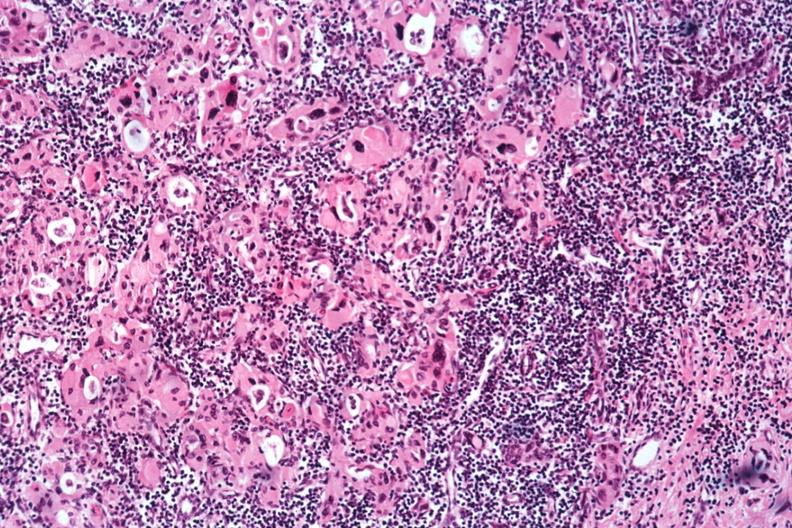s autoimmune thyroiditis present?
Answer the question using a single word or phrase. Yes 